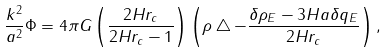Convert formula to latex. <formula><loc_0><loc_0><loc_500><loc_500>\frac { k ^ { 2 } } { a ^ { 2 } } \Phi = 4 \pi G \left ( \frac { 2 H r _ { c } } { 2 H r _ { c } - 1 } \right ) \left ( \rho \bigtriangleup - \frac { \delta \rho _ { E } - 3 H a \delta q _ { E } } { 2 H r _ { c } } \right ) ,</formula> 